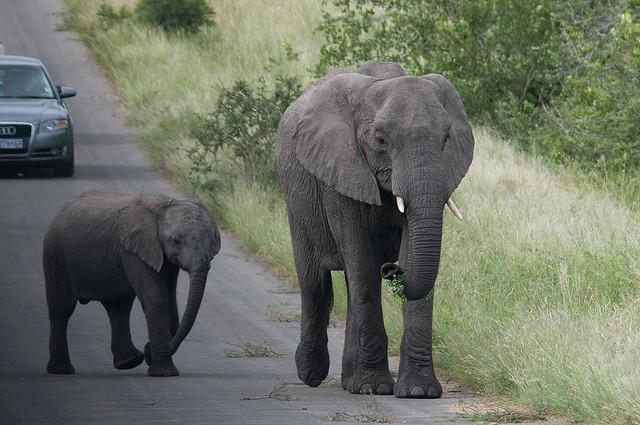Are they hindering traffic?
Short answer required. Yes. Are these elephants walking on a street?
Concise answer only. Yes. Is the baby following the big elephant?
Answer briefly. Yes. How tall is the bigger elephant?
Be succinct. 10 feet. What is the composition of the road?
Short answer required. Cement. 